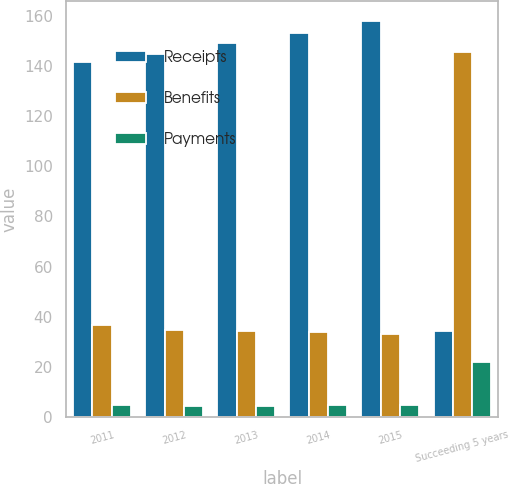Convert chart to OTSL. <chart><loc_0><loc_0><loc_500><loc_500><stacked_bar_chart><ecel><fcel>2011<fcel>2012<fcel>2013<fcel>2014<fcel>2015<fcel>Succeeding 5 years<nl><fcel>Receipts<fcel>141.6<fcel>144.9<fcel>149.2<fcel>153.4<fcel>158.2<fcel>34.3<nl><fcel>Benefits<fcel>36.5<fcel>34.7<fcel>34.3<fcel>33.8<fcel>33<fcel>145.9<nl><fcel>Payments<fcel>4.5<fcel>4.3<fcel>4.4<fcel>4.5<fcel>4.5<fcel>22<nl></chart> 